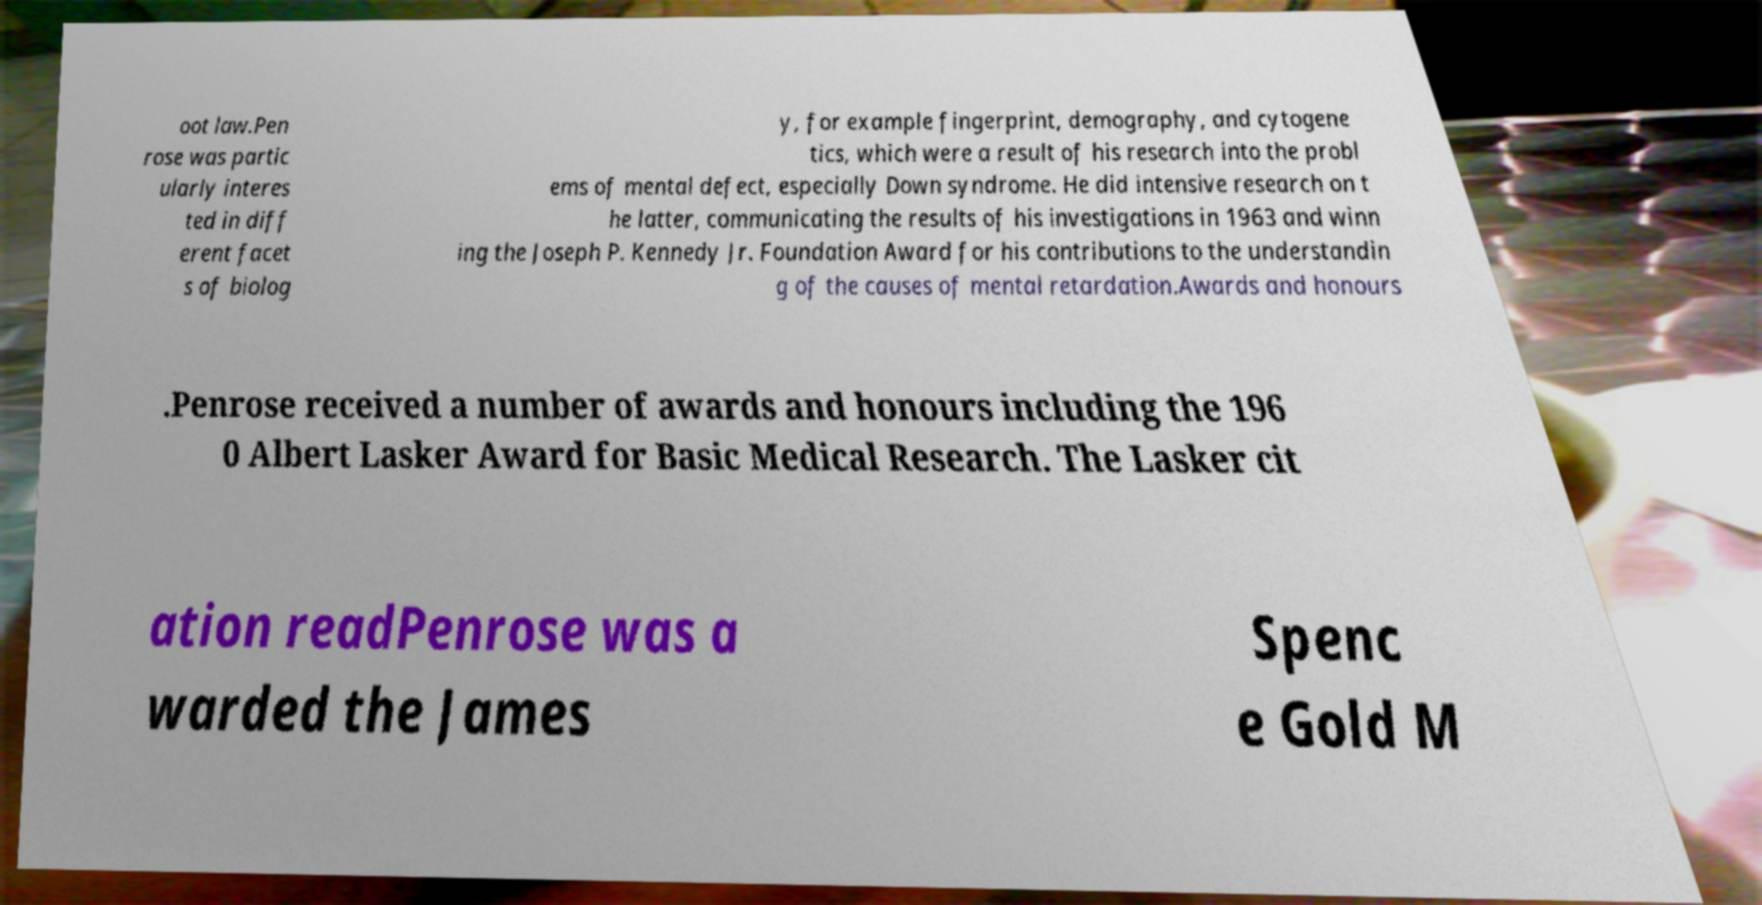There's text embedded in this image that I need extracted. Can you transcribe it verbatim? oot law.Pen rose was partic ularly interes ted in diff erent facet s of biolog y, for example fingerprint, demography, and cytogene tics, which were a result of his research into the probl ems of mental defect, especially Down syndrome. He did intensive research on t he latter, communicating the results of his investigations in 1963 and winn ing the Joseph P. Kennedy Jr. Foundation Award for his contributions to the understandin g of the causes of mental retardation.Awards and honours .Penrose received a number of awards and honours including the 196 0 Albert Lasker Award for Basic Medical Research. The Lasker cit ation readPenrose was a warded the James Spenc e Gold M 